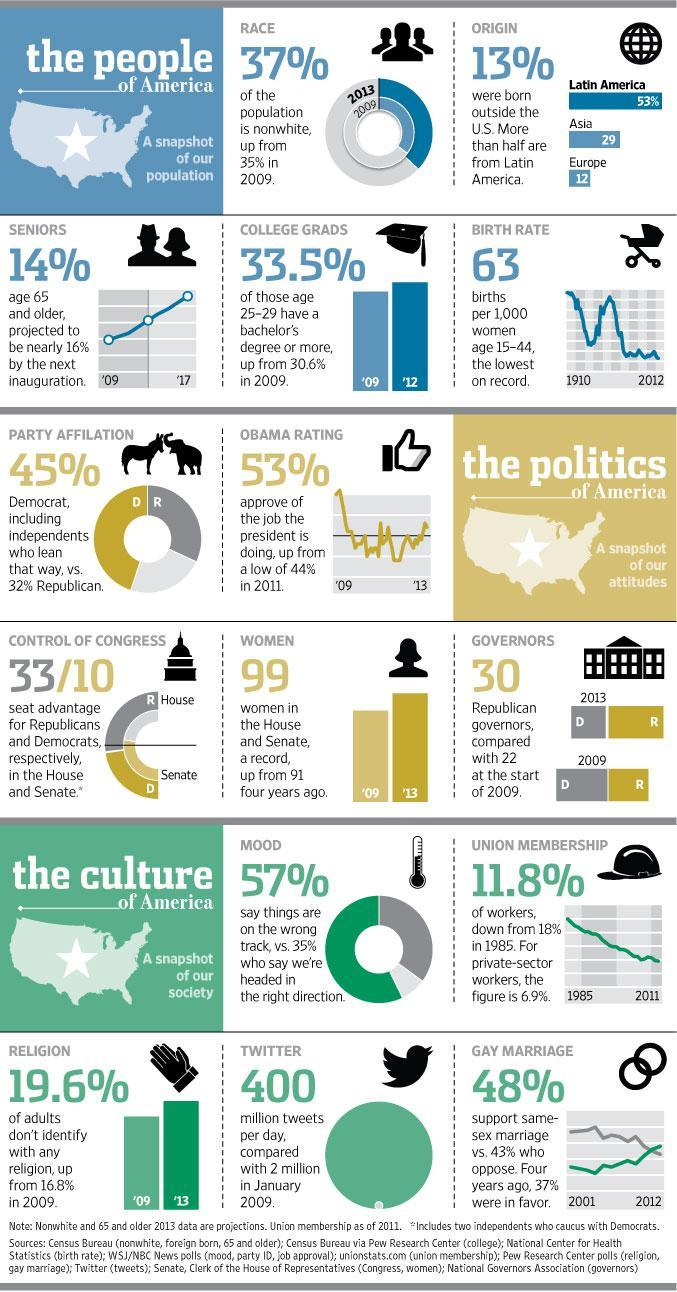How many women were in the House and senate in 2009?
Answer the question with a short phrase. 91 What percent of people in their late 20's hold a bachelor's degree or more? 33.5% What is the current approval percentage for the President? 53% What has gone up from 2 million to 400 million from 2009 to 2013? tweets per day What is the current birth rate (per thousand)? 63 What was the percent of workers who had taken Union membership during the year 1985? 18% How many of the governors are Republicans? 30 